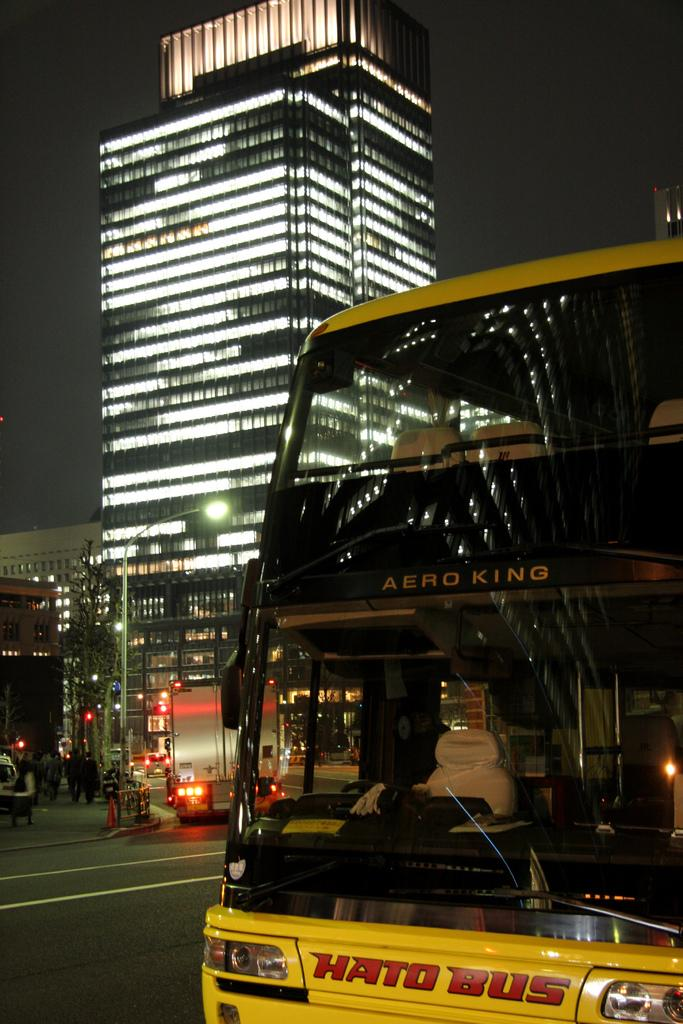<image>
Share a concise interpretation of the image provided. the word bus is on the front of the vehicle 